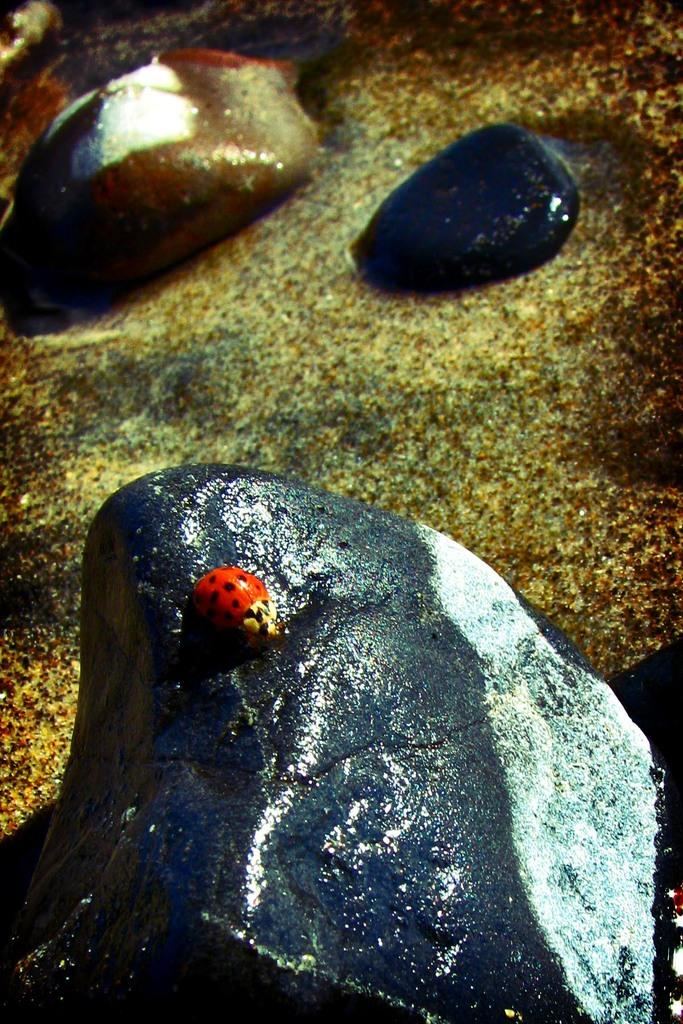What is on the rock in the image? There is an insect on a rock in the image. How many rocks are visible on the ground in the image? There are three rocks on the ground in the image. What type of cactus can be seen growing near the rocks in the image? There is no cactus present in the image; it only features an insect on a rock and three rocks on the ground. 